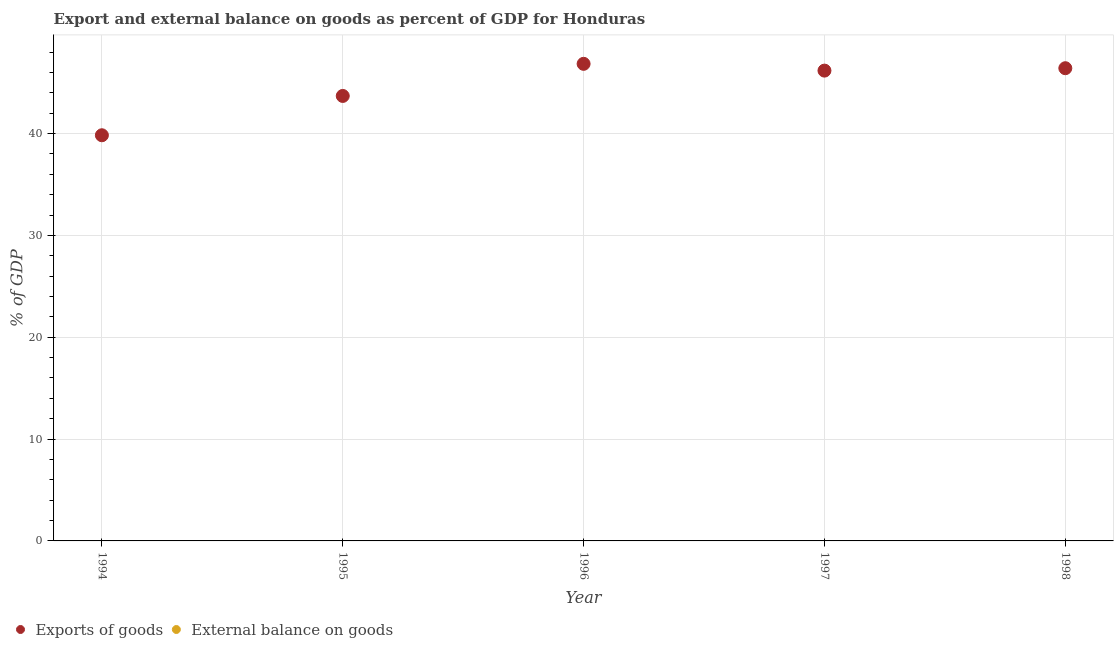How many different coloured dotlines are there?
Your answer should be very brief. 1. Is the number of dotlines equal to the number of legend labels?
Provide a succinct answer. No. What is the external balance on goods as percentage of gdp in 1994?
Offer a terse response. 0. Across all years, what is the maximum export of goods as percentage of gdp?
Provide a succinct answer. 46.85. What is the total external balance on goods as percentage of gdp in the graph?
Your answer should be compact. 0. What is the difference between the export of goods as percentage of gdp in 1996 and that in 1998?
Your response must be concise. 0.43. What is the difference between the export of goods as percentage of gdp in 1994 and the external balance on goods as percentage of gdp in 1998?
Keep it short and to the point. 39.84. What is the average export of goods as percentage of gdp per year?
Offer a terse response. 44.6. What is the ratio of the export of goods as percentage of gdp in 1995 to that in 1996?
Offer a very short reply. 0.93. What is the difference between the highest and the second highest export of goods as percentage of gdp?
Make the answer very short. 0.43. What is the difference between the highest and the lowest export of goods as percentage of gdp?
Provide a short and direct response. 7.01. Is the sum of the export of goods as percentage of gdp in 1994 and 1997 greater than the maximum external balance on goods as percentage of gdp across all years?
Give a very brief answer. Yes. Does the export of goods as percentage of gdp monotonically increase over the years?
Your answer should be compact. No. Is the external balance on goods as percentage of gdp strictly greater than the export of goods as percentage of gdp over the years?
Give a very brief answer. No. Is the external balance on goods as percentage of gdp strictly less than the export of goods as percentage of gdp over the years?
Make the answer very short. Yes. How many dotlines are there?
Give a very brief answer. 1. How many years are there in the graph?
Offer a terse response. 5. Are the values on the major ticks of Y-axis written in scientific E-notation?
Provide a succinct answer. No. Does the graph contain grids?
Give a very brief answer. Yes. How many legend labels are there?
Provide a succinct answer. 2. How are the legend labels stacked?
Give a very brief answer. Horizontal. What is the title of the graph?
Provide a short and direct response. Export and external balance on goods as percent of GDP for Honduras. What is the label or title of the X-axis?
Give a very brief answer. Year. What is the label or title of the Y-axis?
Provide a short and direct response. % of GDP. What is the % of GDP in Exports of goods in 1994?
Keep it short and to the point. 39.84. What is the % of GDP of Exports of goods in 1995?
Give a very brief answer. 43.7. What is the % of GDP in Exports of goods in 1996?
Your answer should be compact. 46.85. What is the % of GDP in Exports of goods in 1997?
Your answer should be compact. 46.19. What is the % of GDP in Exports of goods in 1998?
Keep it short and to the point. 46.42. What is the % of GDP in External balance on goods in 1998?
Your answer should be very brief. 0. Across all years, what is the maximum % of GDP in Exports of goods?
Your response must be concise. 46.85. Across all years, what is the minimum % of GDP in Exports of goods?
Keep it short and to the point. 39.84. What is the total % of GDP in Exports of goods in the graph?
Your answer should be compact. 223. What is the total % of GDP of External balance on goods in the graph?
Ensure brevity in your answer.  0. What is the difference between the % of GDP of Exports of goods in 1994 and that in 1995?
Provide a short and direct response. -3.86. What is the difference between the % of GDP in Exports of goods in 1994 and that in 1996?
Ensure brevity in your answer.  -7.01. What is the difference between the % of GDP of Exports of goods in 1994 and that in 1997?
Make the answer very short. -6.35. What is the difference between the % of GDP of Exports of goods in 1994 and that in 1998?
Your answer should be compact. -6.58. What is the difference between the % of GDP in Exports of goods in 1995 and that in 1996?
Your response must be concise. -3.15. What is the difference between the % of GDP of Exports of goods in 1995 and that in 1997?
Provide a succinct answer. -2.49. What is the difference between the % of GDP of Exports of goods in 1995 and that in 1998?
Your answer should be compact. -2.72. What is the difference between the % of GDP in Exports of goods in 1996 and that in 1997?
Give a very brief answer. 0.67. What is the difference between the % of GDP of Exports of goods in 1996 and that in 1998?
Give a very brief answer. 0.43. What is the difference between the % of GDP in Exports of goods in 1997 and that in 1998?
Make the answer very short. -0.24. What is the average % of GDP of Exports of goods per year?
Ensure brevity in your answer.  44.6. What is the average % of GDP of External balance on goods per year?
Ensure brevity in your answer.  0. What is the ratio of the % of GDP of Exports of goods in 1994 to that in 1995?
Offer a terse response. 0.91. What is the ratio of the % of GDP in Exports of goods in 1994 to that in 1996?
Make the answer very short. 0.85. What is the ratio of the % of GDP of Exports of goods in 1994 to that in 1997?
Keep it short and to the point. 0.86. What is the ratio of the % of GDP in Exports of goods in 1994 to that in 1998?
Keep it short and to the point. 0.86. What is the ratio of the % of GDP in Exports of goods in 1995 to that in 1996?
Keep it short and to the point. 0.93. What is the ratio of the % of GDP of Exports of goods in 1995 to that in 1997?
Your answer should be compact. 0.95. What is the ratio of the % of GDP of Exports of goods in 1995 to that in 1998?
Ensure brevity in your answer.  0.94. What is the ratio of the % of GDP in Exports of goods in 1996 to that in 1997?
Your answer should be compact. 1.01. What is the ratio of the % of GDP in Exports of goods in 1996 to that in 1998?
Offer a very short reply. 1.01. What is the difference between the highest and the second highest % of GDP of Exports of goods?
Your response must be concise. 0.43. What is the difference between the highest and the lowest % of GDP in Exports of goods?
Keep it short and to the point. 7.01. 